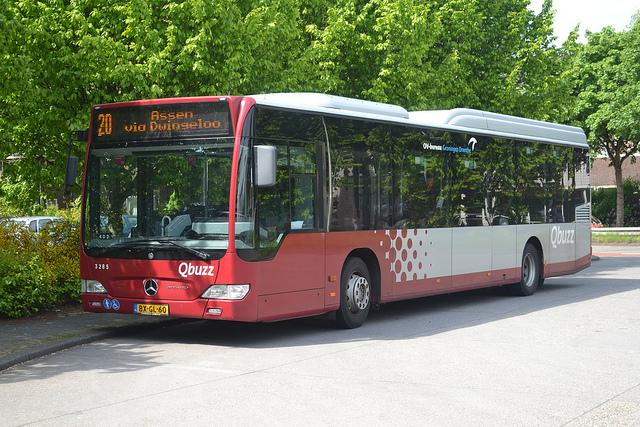What group of people are accommodated in this bus? Please explain your reasoning. handicapped. The bus can accommodate handicapped people. 